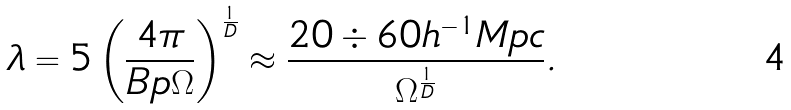Convert formula to latex. <formula><loc_0><loc_0><loc_500><loc_500>\lambda = 5 \left ( \frac { 4 \pi } { B p \Omega } \right ) ^ { \frac { 1 } { D } } \approx \frac { 2 0 \div 6 0 h ^ { - 1 } M p c } { \Omega ^ { \frac { 1 } { D } } } .</formula> 